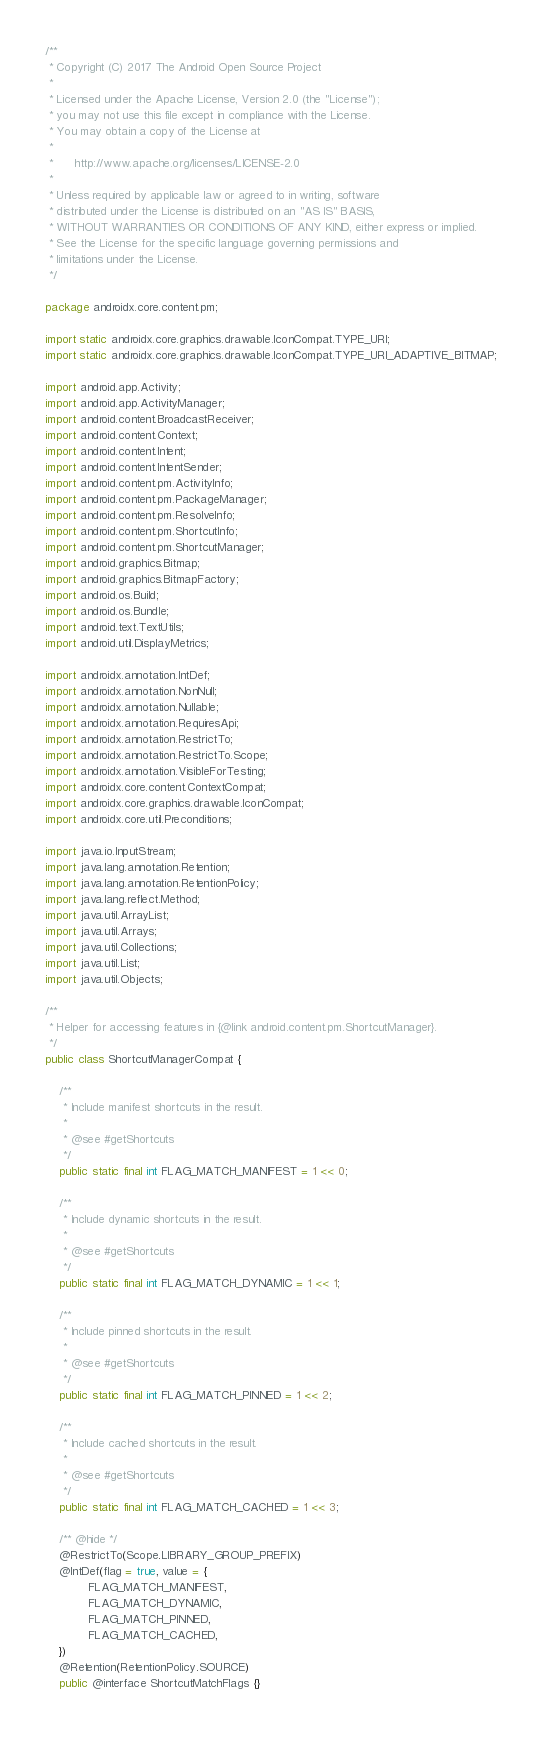<code> <loc_0><loc_0><loc_500><loc_500><_Java_>/**
 * Copyright (C) 2017 The Android Open Source Project
 *
 * Licensed under the Apache License, Version 2.0 (the "License");
 * you may not use this file except in compliance with the License.
 * You may obtain a copy of the License at
 *
 *      http://www.apache.org/licenses/LICENSE-2.0
 *
 * Unless required by applicable law or agreed to in writing, software
 * distributed under the License is distributed on an "AS IS" BASIS,
 * WITHOUT WARRANTIES OR CONDITIONS OF ANY KIND, either express or implied.
 * See the License for the specific language governing permissions and
 * limitations under the License.
 */

package androidx.core.content.pm;

import static androidx.core.graphics.drawable.IconCompat.TYPE_URI;
import static androidx.core.graphics.drawable.IconCompat.TYPE_URI_ADAPTIVE_BITMAP;

import android.app.Activity;
import android.app.ActivityManager;
import android.content.BroadcastReceiver;
import android.content.Context;
import android.content.Intent;
import android.content.IntentSender;
import android.content.pm.ActivityInfo;
import android.content.pm.PackageManager;
import android.content.pm.ResolveInfo;
import android.content.pm.ShortcutInfo;
import android.content.pm.ShortcutManager;
import android.graphics.Bitmap;
import android.graphics.BitmapFactory;
import android.os.Build;
import android.os.Bundle;
import android.text.TextUtils;
import android.util.DisplayMetrics;

import androidx.annotation.IntDef;
import androidx.annotation.NonNull;
import androidx.annotation.Nullable;
import androidx.annotation.RequiresApi;
import androidx.annotation.RestrictTo;
import androidx.annotation.RestrictTo.Scope;
import androidx.annotation.VisibleForTesting;
import androidx.core.content.ContextCompat;
import androidx.core.graphics.drawable.IconCompat;
import androidx.core.util.Preconditions;

import java.io.InputStream;
import java.lang.annotation.Retention;
import java.lang.annotation.RetentionPolicy;
import java.lang.reflect.Method;
import java.util.ArrayList;
import java.util.Arrays;
import java.util.Collections;
import java.util.List;
import java.util.Objects;

/**
 * Helper for accessing features in {@link android.content.pm.ShortcutManager}.
 */
public class ShortcutManagerCompat {

    /**
     * Include manifest shortcuts in the result.
     *
     * @see #getShortcuts
     */
    public static final int FLAG_MATCH_MANIFEST = 1 << 0;

    /**
     * Include dynamic shortcuts in the result.
     *
     * @see #getShortcuts
     */
    public static final int FLAG_MATCH_DYNAMIC = 1 << 1;

    /**
     * Include pinned shortcuts in the result.
     *
     * @see #getShortcuts
     */
    public static final int FLAG_MATCH_PINNED = 1 << 2;

    /**
     * Include cached shortcuts in the result.
     *
     * @see #getShortcuts
     */
    public static final int FLAG_MATCH_CACHED = 1 << 3;

    /** @hide */
    @RestrictTo(Scope.LIBRARY_GROUP_PREFIX)
    @IntDef(flag = true, value = {
            FLAG_MATCH_MANIFEST,
            FLAG_MATCH_DYNAMIC,
            FLAG_MATCH_PINNED,
            FLAG_MATCH_CACHED,
    })
    @Retention(RetentionPolicy.SOURCE)
    public @interface ShortcutMatchFlags {}
</code> 